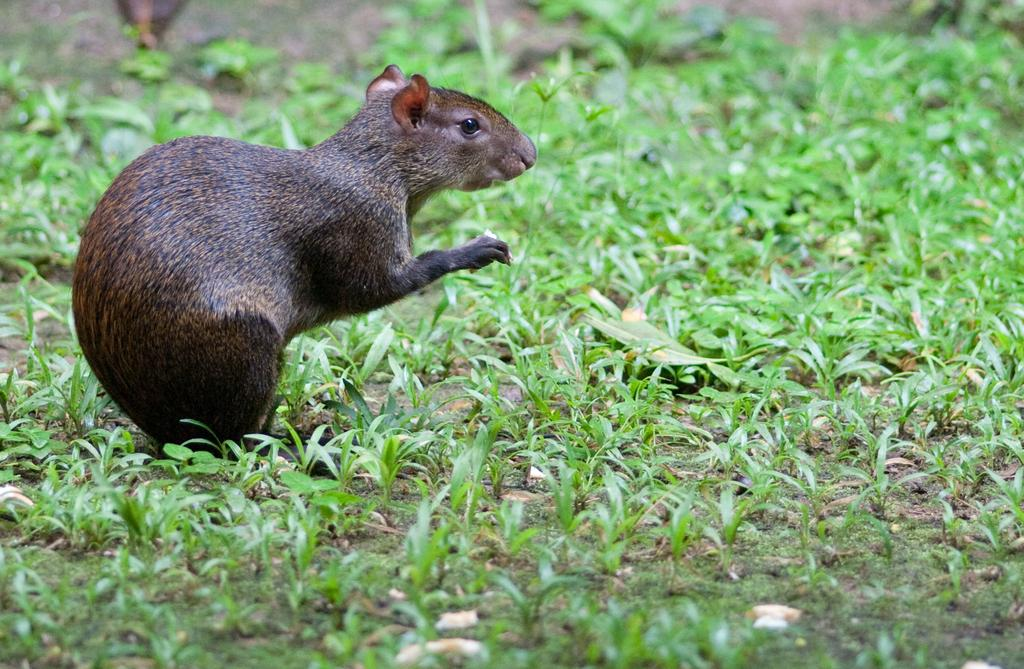What type of surface is visible in the image? There is ground visible in the image. What kind of vegetation is present on the ground? There is grass on the ground. What animal can be seen in the image? There is a rat in the image. What colors are present on the rat? The rat is brown and black in color. How many wheels are visible on the rat in the image? There are no wheels visible on the rat in the image, as rats do not have wheels. 